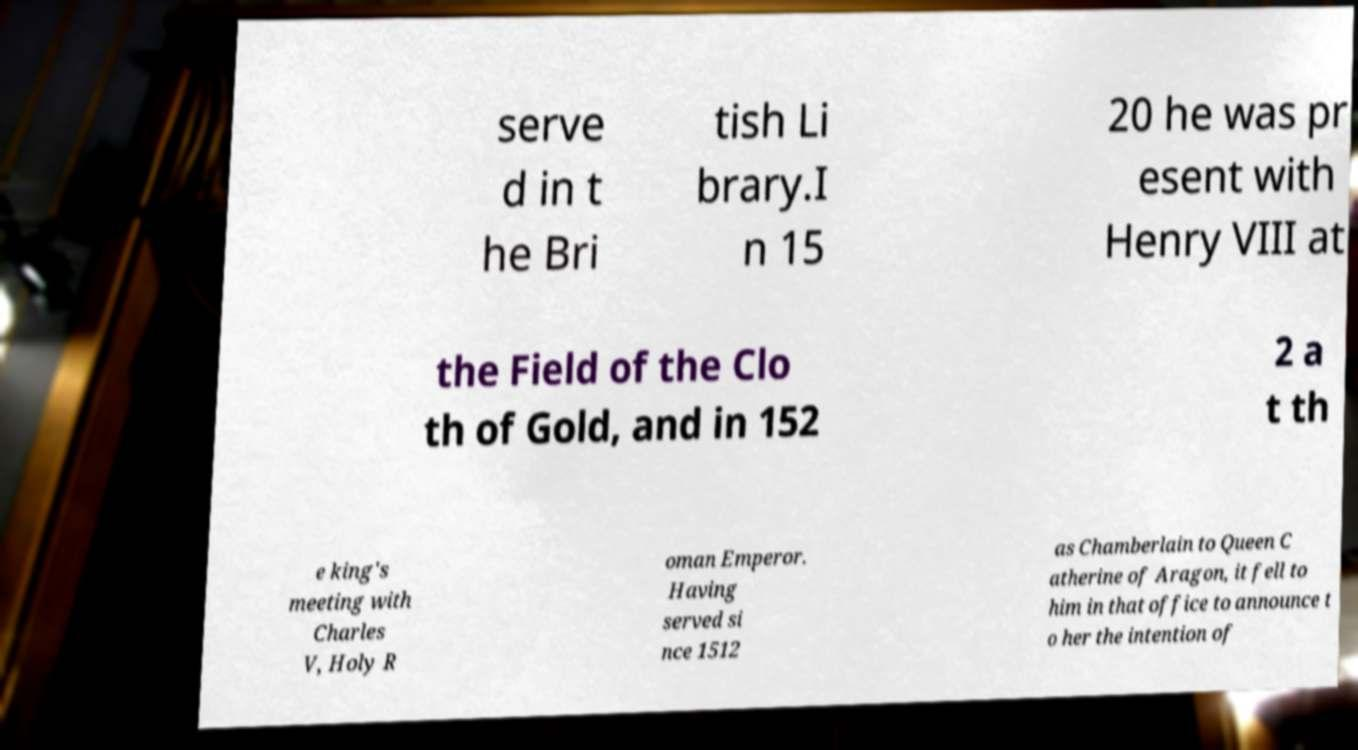Can you accurately transcribe the text from the provided image for me? serve d in t he Bri tish Li brary.I n 15 20 he was pr esent with Henry VIII at the Field of the Clo th of Gold, and in 152 2 a t th e king's meeting with Charles V, Holy R oman Emperor. Having served si nce 1512 as Chamberlain to Queen C atherine of Aragon, it fell to him in that office to announce t o her the intention of 